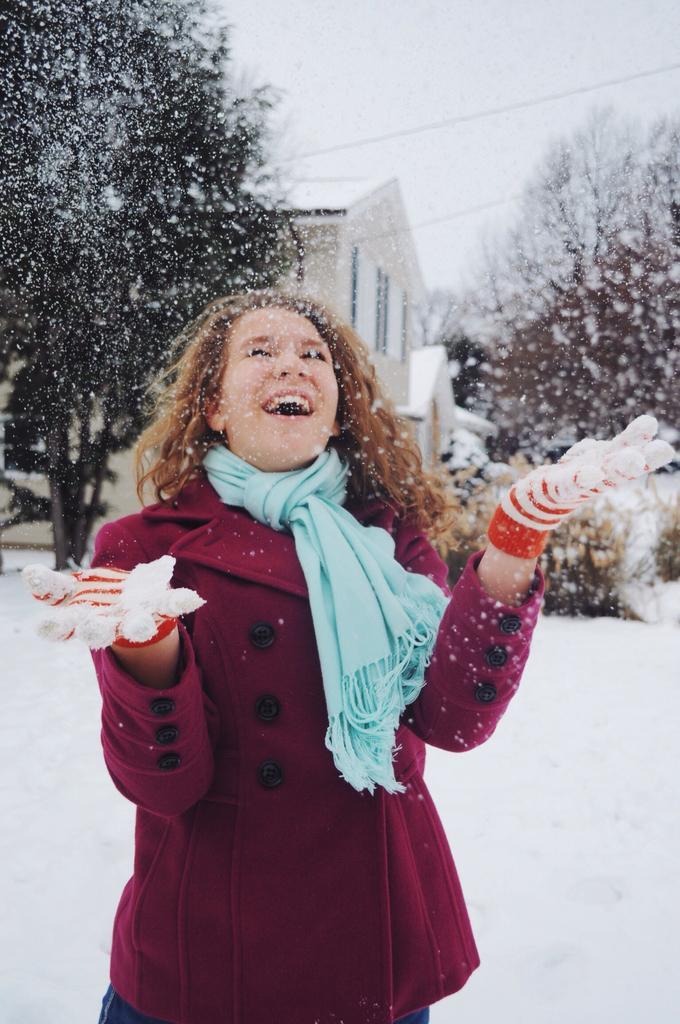How would you summarize this image in a sentence or two? In the foreground of the picture I can see a woman and there is a smile on her face. I can see the gloves on her hands and there is a scarf on her neck. In the background, I can see the house, trees and snow. These are looking like electric wires on the top right side of the picture. 